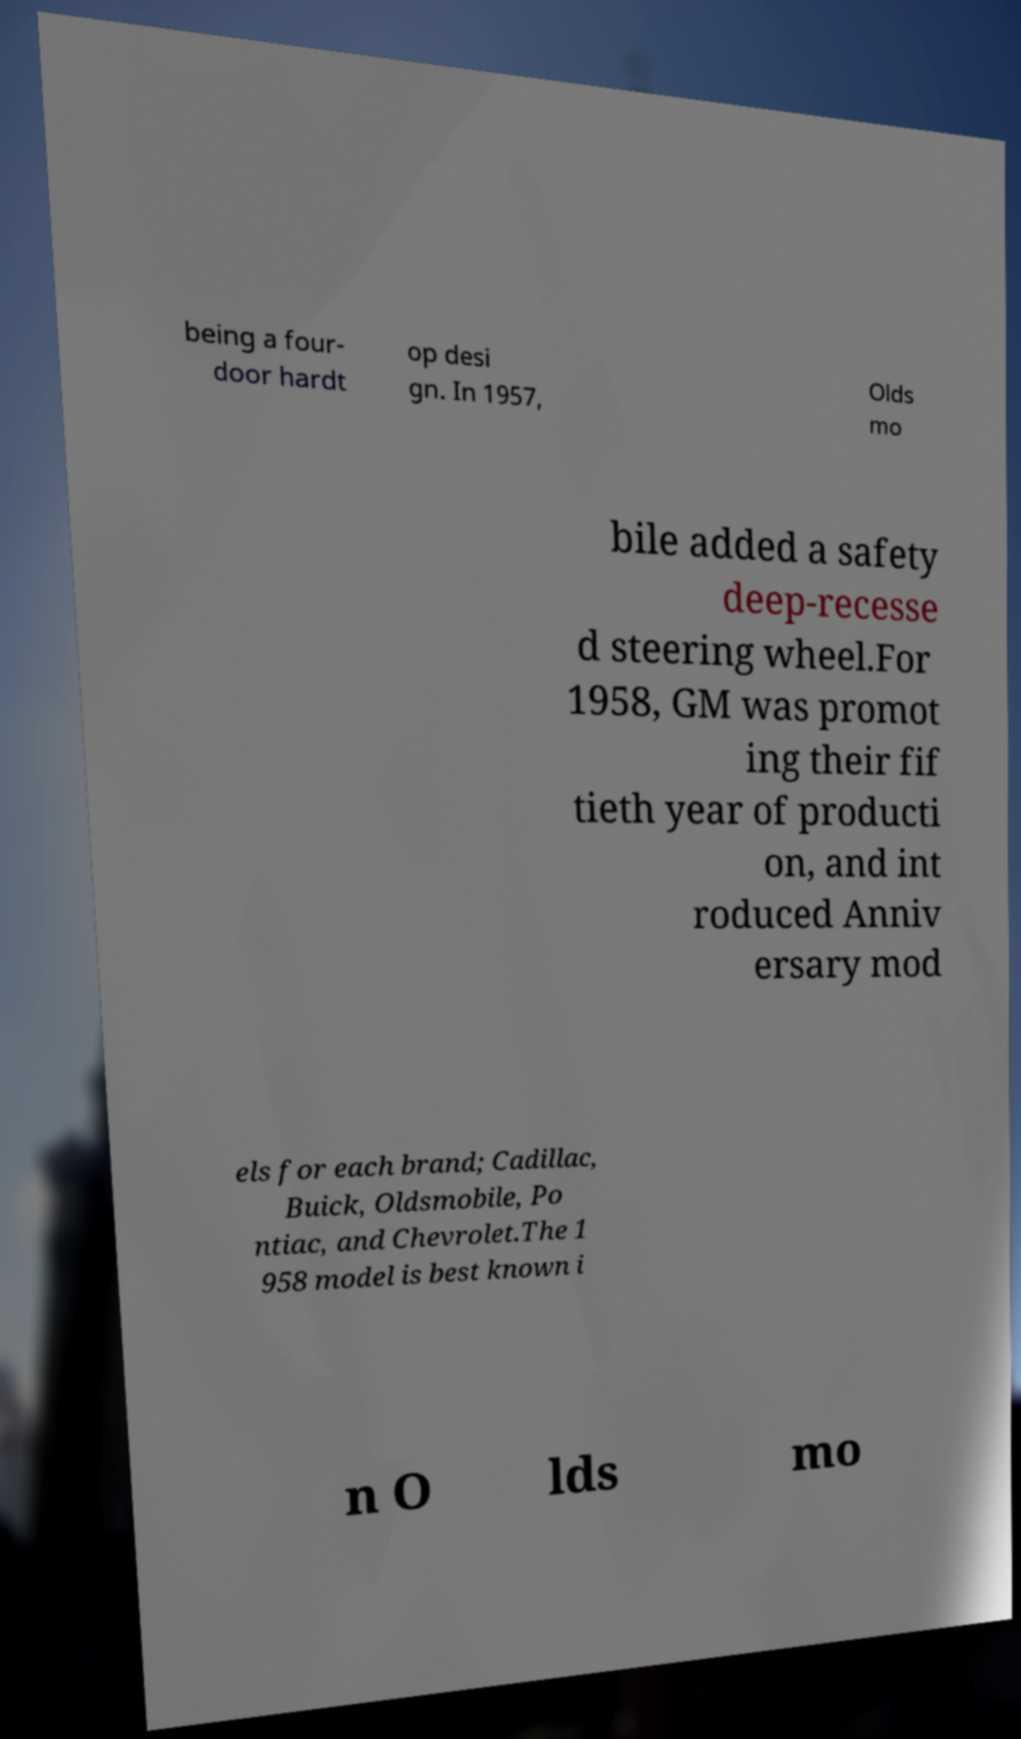Could you assist in decoding the text presented in this image and type it out clearly? being a four- door hardt op desi gn. In 1957, Olds mo bile added a safety deep-recesse d steering wheel.For 1958, GM was promot ing their fif tieth year of producti on, and int roduced Anniv ersary mod els for each brand; Cadillac, Buick, Oldsmobile, Po ntiac, and Chevrolet.The 1 958 model is best known i n O lds mo 